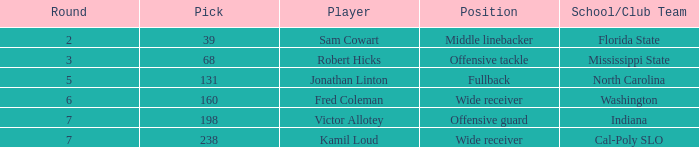Which school/club team possesses a selection of 198? Indiana. 